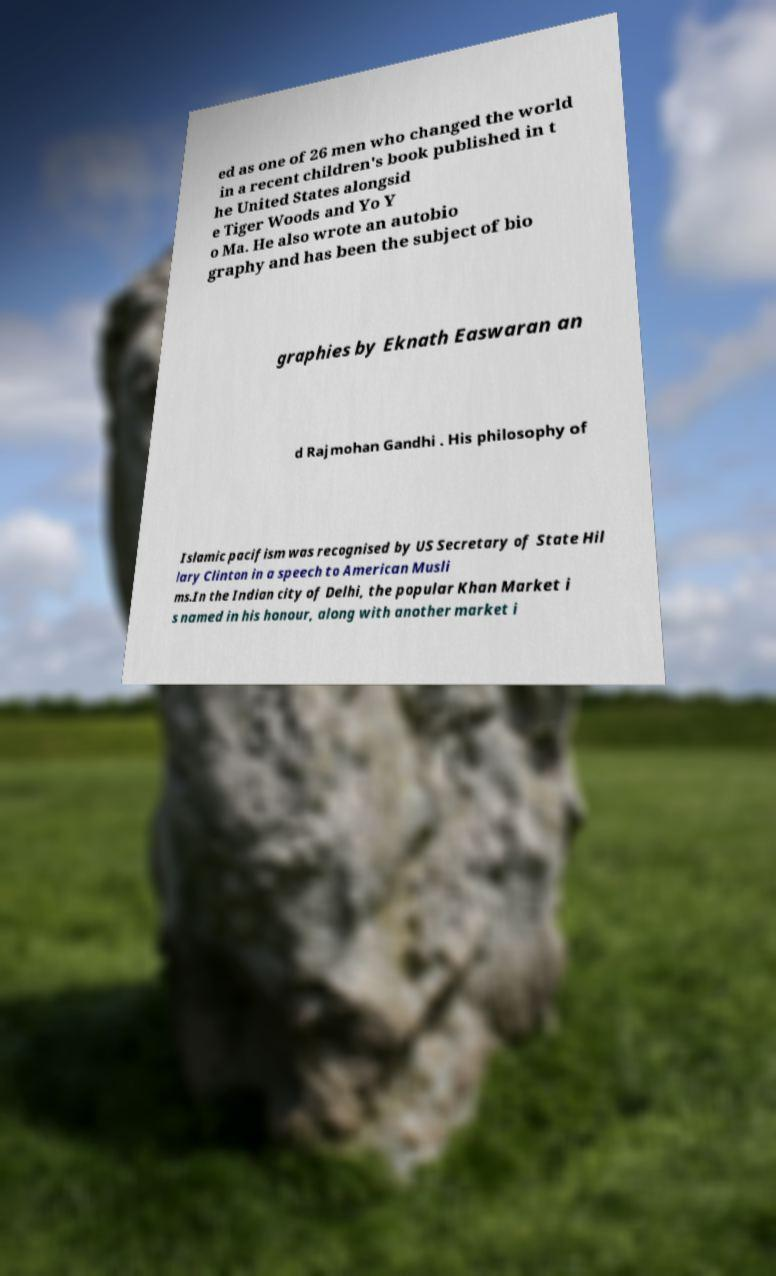Can you read and provide the text displayed in the image?This photo seems to have some interesting text. Can you extract and type it out for me? ed as one of 26 men who changed the world in a recent children's book published in t he United States alongsid e Tiger Woods and Yo Y o Ma. He also wrote an autobio graphy and has been the subject of bio graphies by Eknath Easwaran an d Rajmohan Gandhi . His philosophy of Islamic pacifism was recognised by US Secretary of State Hil lary Clinton in a speech to American Musli ms.In the Indian city of Delhi, the popular Khan Market i s named in his honour, along with another market i 